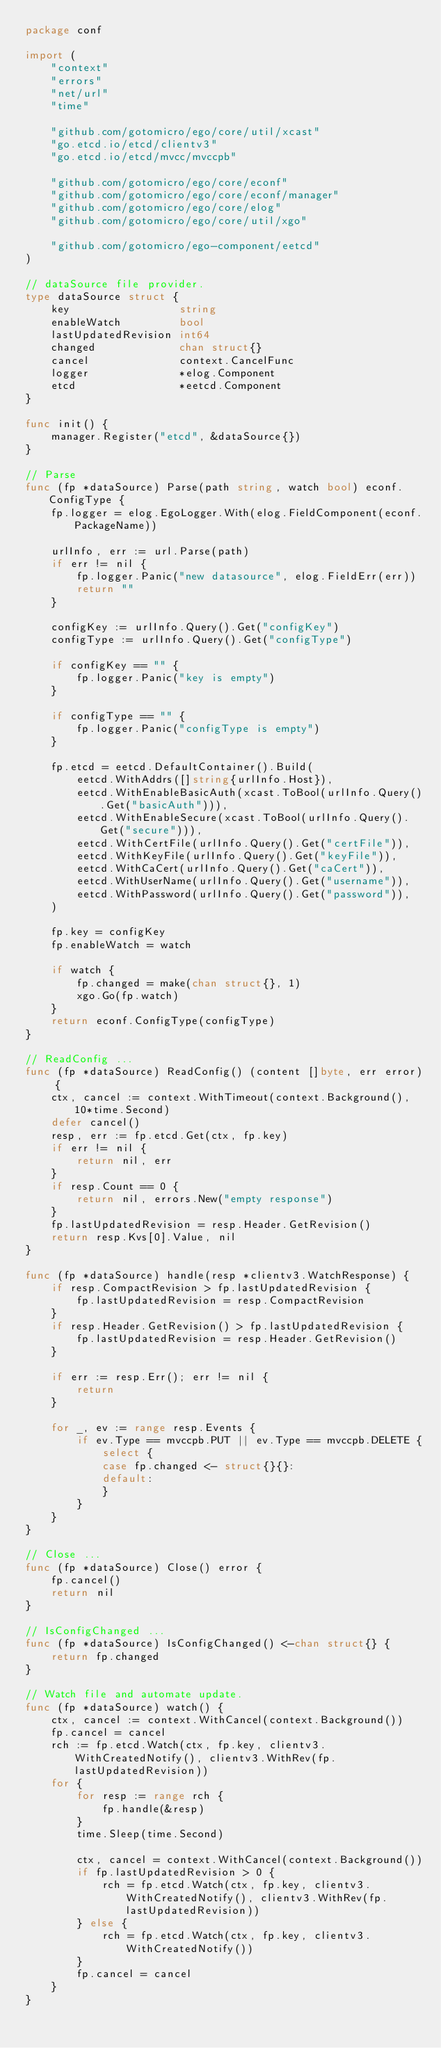Convert code to text. <code><loc_0><loc_0><loc_500><loc_500><_Go_>package conf

import (
	"context"
	"errors"
	"net/url"
	"time"

	"github.com/gotomicro/ego/core/util/xcast"
	"go.etcd.io/etcd/clientv3"
	"go.etcd.io/etcd/mvcc/mvccpb"

	"github.com/gotomicro/ego/core/econf"
	"github.com/gotomicro/ego/core/econf/manager"
	"github.com/gotomicro/ego/core/elog"
	"github.com/gotomicro/ego/core/util/xgo"

	"github.com/gotomicro/ego-component/eetcd"
)

// dataSource file provider.
type dataSource struct {
	key                 string
	enableWatch         bool
	lastUpdatedRevision int64
	changed             chan struct{}
	cancel              context.CancelFunc
	logger              *elog.Component
	etcd                *eetcd.Component
}

func init() {
	manager.Register("etcd", &dataSource{})
}

// Parse
func (fp *dataSource) Parse(path string, watch bool) econf.ConfigType {
	fp.logger = elog.EgoLogger.With(elog.FieldComponent(econf.PackageName))

	urlInfo, err := url.Parse(path)
	if err != nil {
		fp.logger.Panic("new datasource", elog.FieldErr(err))
		return ""
	}

	configKey := urlInfo.Query().Get("configKey")
	configType := urlInfo.Query().Get("configType")

	if configKey == "" {
		fp.logger.Panic("key is empty")
	}

	if configType == "" {
		fp.logger.Panic("configType is empty")
	}

	fp.etcd = eetcd.DefaultContainer().Build(
		eetcd.WithAddrs([]string{urlInfo.Host}),
		eetcd.WithEnableBasicAuth(xcast.ToBool(urlInfo.Query().Get("basicAuth"))),
		eetcd.WithEnableSecure(xcast.ToBool(urlInfo.Query().Get("secure"))),
		eetcd.WithCertFile(urlInfo.Query().Get("certFile")),
		eetcd.WithKeyFile(urlInfo.Query().Get("keyFile")),
		eetcd.WithCaCert(urlInfo.Query().Get("caCert")),
		eetcd.WithUserName(urlInfo.Query().Get("username")),
		eetcd.WithPassword(urlInfo.Query().Get("password")),
	)

	fp.key = configKey
	fp.enableWatch = watch

	if watch {
		fp.changed = make(chan struct{}, 1)
		xgo.Go(fp.watch)
	}
	return econf.ConfigType(configType)
}

// ReadConfig ...
func (fp *dataSource) ReadConfig() (content []byte, err error) {
	ctx, cancel := context.WithTimeout(context.Background(), 10*time.Second)
	defer cancel()
	resp, err := fp.etcd.Get(ctx, fp.key)
	if err != nil {
		return nil, err
	}
	if resp.Count == 0 {
		return nil, errors.New("empty response")
	}
	fp.lastUpdatedRevision = resp.Header.GetRevision()
	return resp.Kvs[0].Value, nil
}

func (fp *dataSource) handle(resp *clientv3.WatchResponse) {
	if resp.CompactRevision > fp.lastUpdatedRevision {
		fp.lastUpdatedRevision = resp.CompactRevision
	}
	if resp.Header.GetRevision() > fp.lastUpdatedRevision {
		fp.lastUpdatedRevision = resp.Header.GetRevision()
	}

	if err := resp.Err(); err != nil {
		return
	}

	for _, ev := range resp.Events {
		if ev.Type == mvccpb.PUT || ev.Type == mvccpb.DELETE {
			select {
			case fp.changed <- struct{}{}:
			default:
			}
		}
	}
}

// Close ...
func (fp *dataSource) Close() error {
	fp.cancel()
	return nil
}

// IsConfigChanged ...
func (fp *dataSource) IsConfigChanged() <-chan struct{} {
	return fp.changed
}

// Watch file and automate update.
func (fp *dataSource) watch() {
	ctx, cancel := context.WithCancel(context.Background())
	fp.cancel = cancel
	rch := fp.etcd.Watch(ctx, fp.key, clientv3.WithCreatedNotify(), clientv3.WithRev(fp.lastUpdatedRevision))
	for {
		for resp := range rch {
			fp.handle(&resp)
		}
		time.Sleep(time.Second)

		ctx, cancel = context.WithCancel(context.Background())
		if fp.lastUpdatedRevision > 0 {
			rch = fp.etcd.Watch(ctx, fp.key, clientv3.WithCreatedNotify(), clientv3.WithRev(fp.lastUpdatedRevision))
		} else {
			rch = fp.etcd.Watch(ctx, fp.key, clientv3.WithCreatedNotify())
		}
		fp.cancel = cancel
	}
}
</code> 